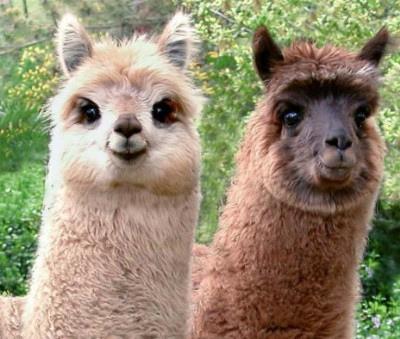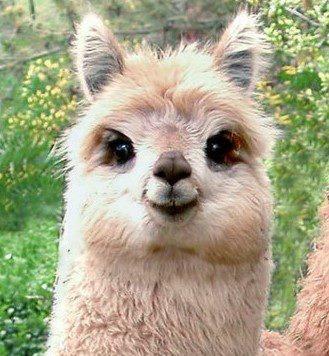The first image is the image on the left, the second image is the image on the right. Analyze the images presented: Is the assertion "The left and right image contains three llamas." valid? Answer yes or no. Yes. 